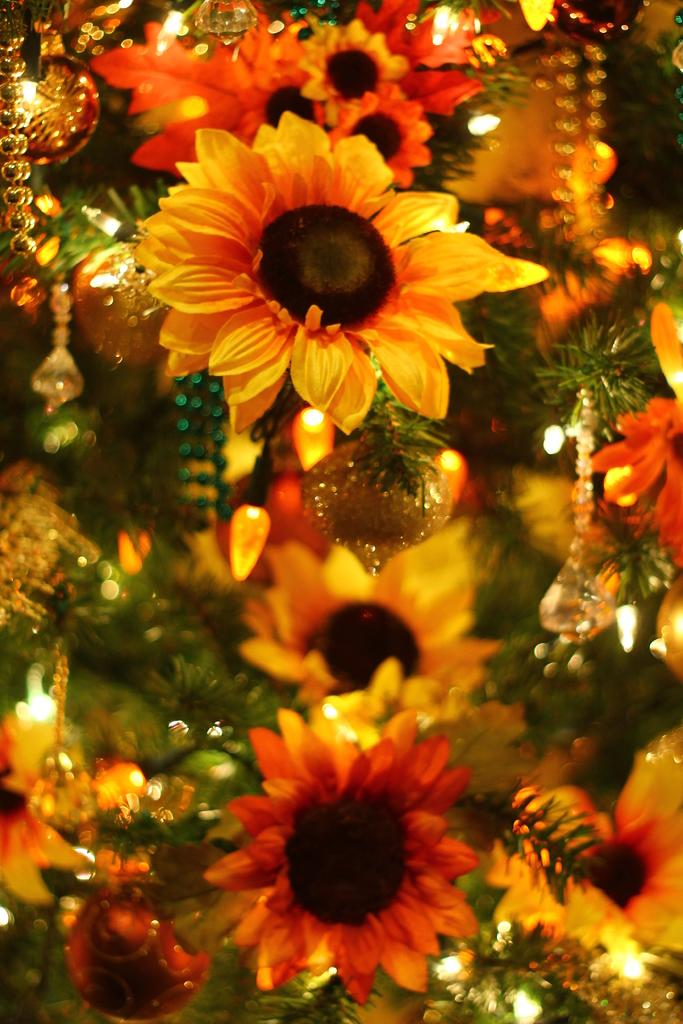What type of flowers are in the image? There are sunflowers in the image. What purpose do the sunflowers serve in the image? The sunflowers are used for decoration. What else can be seen in the image besides the sunflowers? There are lights visible in the image. What type of powder is being used by the fireman in the image? There is no fireman or powder present in the image; it features sunflowers and lights. 